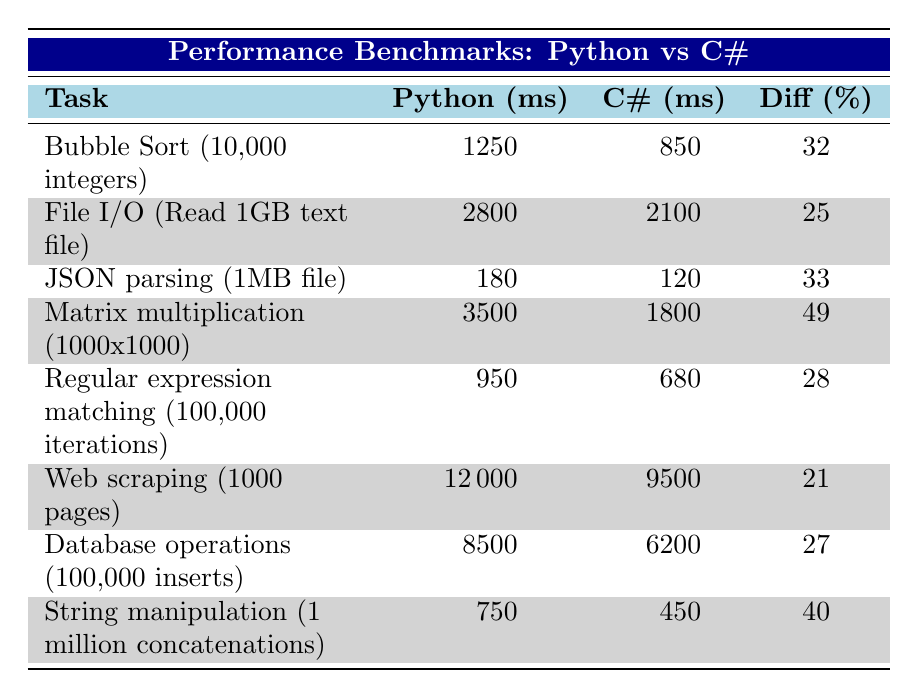What is the execution time for Bubble Sort in Python? The table shows that the execution time for Bubble Sort (10,000 integers) in Python is 1250 ms.
Answer: 1250 ms What is the percentage performance difference for JSON parsing between Python and C#? The table indicates that for JSON parsing (1MB file), Python takes 180 ms while C# takes 120 ms. The performance difference is calculated as ((180 - 120) / 120) * 100 = 33%.
Answer: 33% Which task has the largest performance difference between Python and C#? The performance differences for each task are listed, with Matrix multiplication (1000x1000) showing the largest difference at 49%.
Answer: Matrix multiplication (1000x1000) Is it true that Python outperforms C# in any of the tasks listed? By examining the execution times, Python consistently takes longer for all tasks. Hence, it is false that Python outperforms C#.
Answer: False What is the cumulative execution time for File I/O and Database operations in C#? The execution times in C# for File I/O (2100 ms) and Database operations (6200 ms) can be summed: 2100 + 6200 = 8300 ms.
Answer: 8300 ms On average, how much faster is C# compared to Python for the tasks listed? To find the average execution time for C# and Python, we first calculate the sums. C# total time = 850 + 2100 + 120 + 1800 + 680 + 9500 + 6200 + 450 = 11100 ms; Python total time = 1250 + 2800 + 180 + 3500 + 950 + 12000 + 8500 + 750 = 14930 ms. The average times are 11100 / 8 = 1387.5 ms for C# and 14930 / 8 = 1866.25 ms for Python. The average performance difference is about 25.5%.
Answer: 25.5% How long does it take to perform Web scraping in C#? The execution time for Web scraping (1000 pages) in C# is explicitly stated in the table as 9500 ms.
Answer: 9500 ms What is the performance difference for Regular expression matching? The performance difference is recorded in the table as 28%. This indicates that C# performs significantly better than Python for this task.
Answer: 28% Which programming language is faster for String manipulation tasks? Looking at the table, for String manipulation (1 million concatenations), C# records an execution time of 450 ms, which is faster than Python's 750 ms.
Answer: C# is faster 